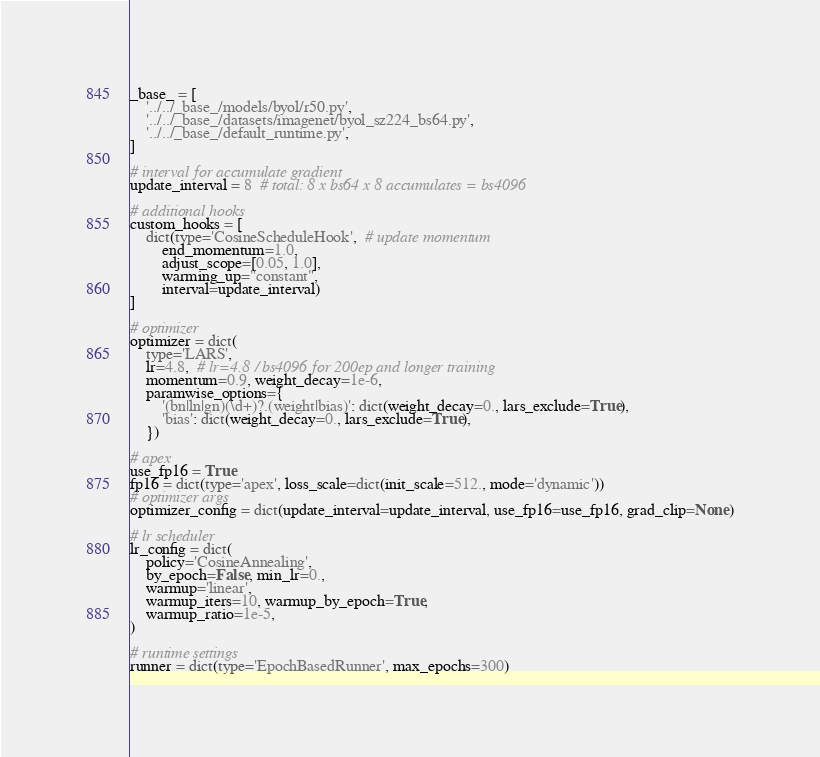Convert code to text. <code><loc_0><loc_0><loc_500><loc_500><_Python_>_base_ = [
    '../../_base_/models/byol/r50.py',
    '../../_base_/datasets/imagenet/byol_sz224_bs64.py',
    '../../_base_/default_runtime.py',
]

# interval for accumulate gradient
update_interval = 8  # total: 8 x bs64 x 8 accumulates = bs4096

# additional hooks
custom_hooks = [
    dict(type='CosineScheduleHook',  # update momentum
        end_momentum=1.0,
        adjust_scope=[0.05, 1.0],
        warming_up="constant",
        interval=update_interval)
]

# optimizer
optimizer = dict(
    type='LARS',
    lr=4.8,  # lr=4.8 / bs4096 for 200ep and longer training
    momentum=0.9, weight_decay=1e-6,
    paramwise_options={
        '(bn|ln|gn)(\d+)?.(weight|bias)': dict(weight_decay=0., lars_exclude=True),
        'bias': dict(weight_decay=0., lars_exclude=True),
    })

# apex
use_fp16 = True
fp16 = dict(type='apex', loss_scale=dict(init_scale=512., mode='dynamic'))
# optimizer args
optimizer_config = dict(update_interval=update_interval, use_fp16=use_fp16, grad_clip=None)

# lr scheduler
lr_config = dict(
    policy='CosineAnnealing',
    by_epoch=False, min_lr=0.,
    warmup='linear',
    warmup_iters=10, warmup_by_epoch=True,
    warmup_ratio=1e-5,
)

# runtime settings
runner = dict(type='EpochBasedRunner', max_epochs=300)
</code> 